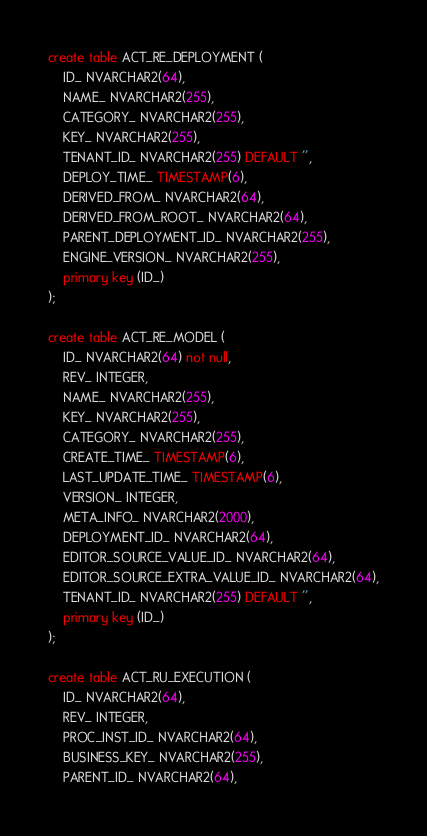Convert code to text. <code><loc_0><loc_0><loc_500><loc_500><_SQL_>create table ACT_RE_DEPLOYMENT (
    ID_ NVARCHAR2(64),
    NAME_ NVARCHAR2(255),
    CATEGORY_ NVARCHAR2(255),
    KEY_ NVARCHAR2(255),
    TENANT_ID_ NVARCHAR2(255) DEFAULT '',
    DEPLOY_TIME_ TIMESTAMP(6),
    DERIVED_FROM_ NVARCHAR2(64),
    DERIVED_FROM_ROOT_ NVARCHAR2(64),
    PARENT_DEPLOYMENT_ID_ NVARCHAR2(255),
    ENGINE_VERSION_ NVARCHAR2(255),
    primary key (ID_)
);

create table ACT_RE_MODEL (
    ID_ NVARCHAR2(64) not null,
    REV_ INTEGER,
    NAME_ NVARCHAR2(255),
    KEY_ NVARCHAR2(255),
    CATEGORY_ NVARCHAR2(255),
    CREATE_TIME_ TIMESTAMP(6),
    LAST_UPDATE_TIME_ TIMESTAMP(6),
    VERSION_ INTEGER,
    META_INFO_ NVARCHAR2(2000),
    DEPLOYMENT_ID_ NVARCHAR2(64),
    EDITOR_SOURCE_VALUE_ID_ NVARCHAR2(64),
    EDITOR_SOURCE_EXTRA_VALUE_ID_ NVARCHAR2(64),
    TENANT_ID_ NVARCHAR2(255) DEFAULT '',
    primary key (ID_)
);

create table ACT_RU_EXECUTION (
    ID_ NVARCHAR2(64),
    REV_ INTEGER,
    PROC_INST_ID_ NVARCHAR2(64),
    BUSINESS_KEY_ NVARCHAR2(255),
    PARENT_ID_ NVARCHAR2(64),</code> 